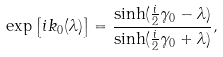<formula> <loc_0><loc_0><loc_500><loc_500>\exp \left [ i k _ { 0 } ( \lambda ) \right ] = \frac { \sinh ( \frac { i } { 2 } \gamma _ { 0 } - \lambda ) } { \sinh ( \frac { i } { 2 } \gamma _ { 0 } + \lambda ) } ,</formula> 